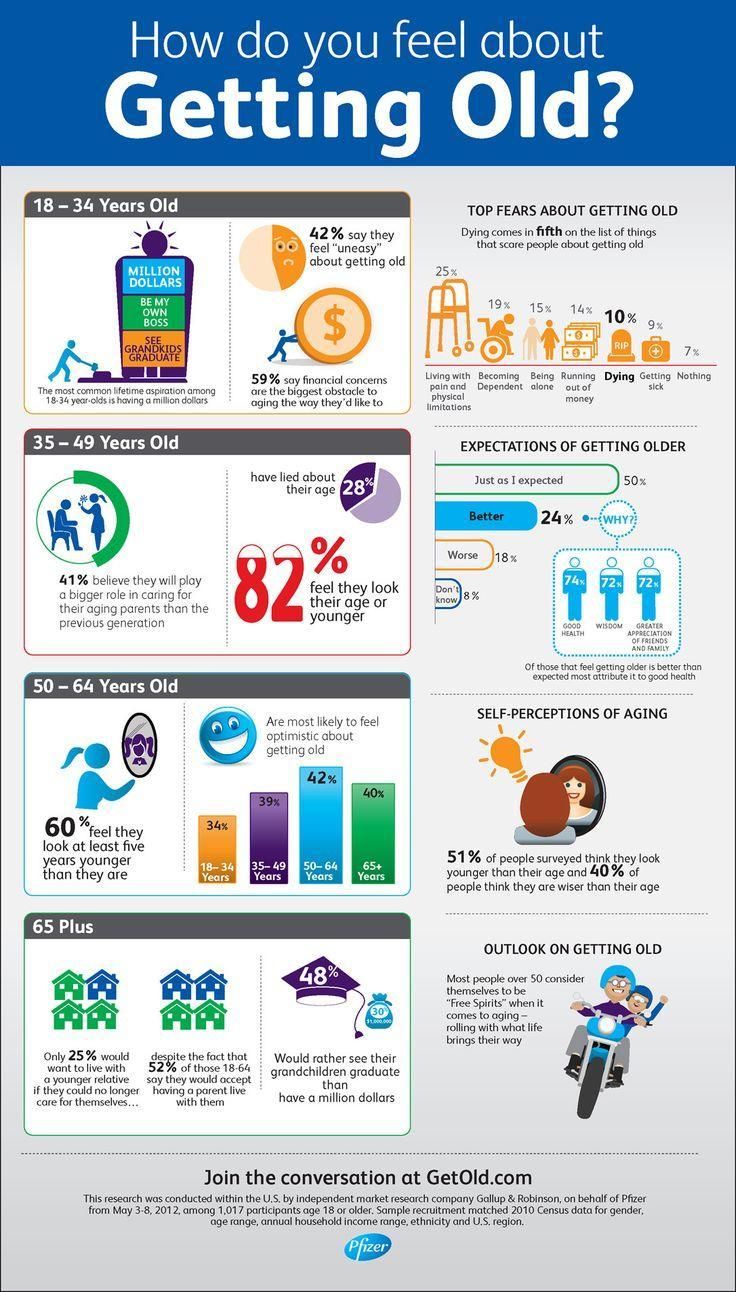What percentage of people didn't think they are wiser than their age?
Answer the question with a short phrase. 60% What percentage of people didn't lied about their age? 18% Which is the second age group feeling optimistic about getting old? 65+ 